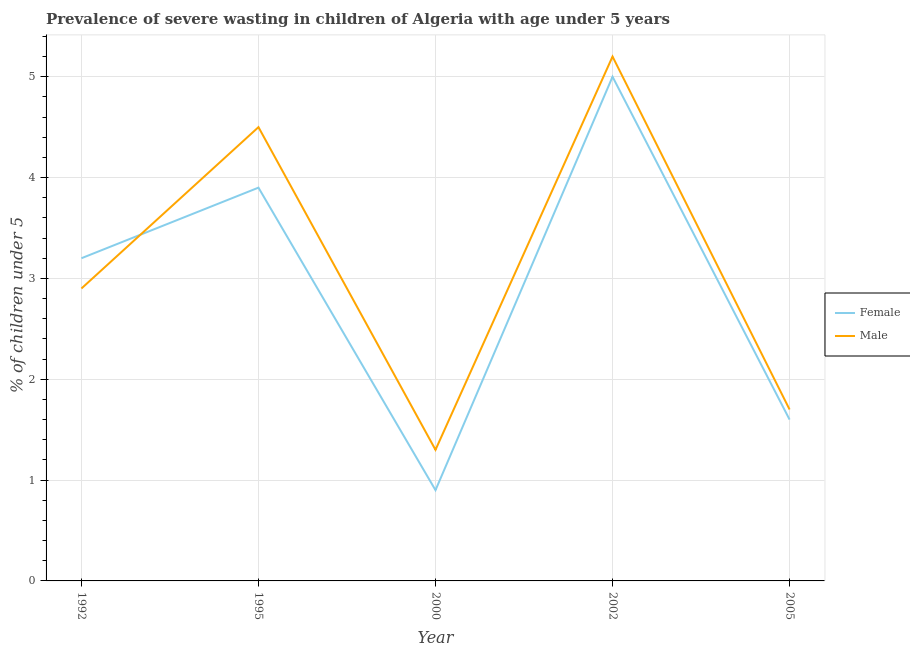Is the number of lines equal to the number of legend labels?
Offer a very short reply. Yes. What is the percentage of undernourished female children in 2000?
Provide a short and direct response. 0.9. Across all years, what is the maximum percentage of undernourished male children?
Keep it short and to the point. 5.2. Across all years, what is the minimum percentage of undernourished female children?
Your answer should be compact. 0.9. In which year was the percentage of undernourished male children minimum?
Your response must be concise. 2000. What is the total percentage of undernourished female children in the graph?
Provide a succinct answer. 14.6. What is the difference between the percentage of undernourished male children in 1992 and that in 2002?
Provide a short and direct response. -2.3. What is the difference between the percentage of undernourished male children in 2005 and the percentage of undernourished female children in 2000?
Make the answer very short. 0.8. What is the average percentage of undernourished female children per year?
Your answer should be very brief. 2.92. In the year 1992, what is the difference between the percentage of undernourished male children and percentage of undernourished female children?
Give a very brief answer. -0.3. What is the ratio of the percentage of undernourished female children in 1995 to that in 2005?
Give a very brief answer. 2.44. Is the difference between the percentage of undernourished male children in 2002 and 2005 greater than the difference between the percentage of undernourished female children in 2002 and 2005?
Offer a terse response. Yes. What is the difference between the highest and the second highest percentage of undernourished male children?
Offer a terse response. 0.7. What is the difference between the highest and the lowest percentage of undernourished female children?
Give a very brief answer. 4.1. In how many years, is the percentage of undernourished male children greater than the average percentage of undernourished male children taken over all years?
Your response must be concise. 2. Is the sum of the percentage of undernourished female children in 1992 and 1995 greater than the maximum percentage of undernourished male children across all years?
Give a very brief answer. Yes. Are the values on the major ticks of Y-axis written in scientific E-notation?
Offer a terse response. No. Does the graph contain any zero values?
Give a very brief answer. No. Does the graph contain grids?
Provide a short and direct response. Yes. Where does the legend appear in the graph?
Offer a terse response. Center right. How many legend labels are there?
Offer a very short reply. 2. What is the title of the graph?
Your answer should be very brief. Prevalence of severe wasting in children of Algeria with age under 5 years. What is the label or title of the Y-axis?
Offer a very short reply.  % of children under 5. What is the  % of children under 5 of Female in 1992?
Provide a short and direct response. 3.2. What is the  % of children under 5 in Male in 1992?
Provide a succinct answer. 2.9. What is the  % of children under 5 in Female in 1995?
Ensure brevity in your answer.  3.9. What is the  % of children under 5 in Male in 1995?
Ensure brevity in your answer.  4.5. What is the  % of children under 5 of Female in 2000?
Offer a very short reply. 0.9. What is the  % of children under 5 in Male in 2000?
Give a very brief answer. 1.3. What is the  % of children under 5 of Female in 2002?
Keep it short and to the point. 5. What is the  % of children under 5 of Male in 2002?
Your response must be concise. 5.2. What is the  % of children under 5 of Female in 2005?
Your answer should be compact. 1.6. What is the  % of children under 5 in Male in 2005?
Provide a short and direct response. 1.7. Across all years, what is the maximum  % of children under 5 of Female?
Ensure brevity in your answer.  5. Across all years, what is the maximum  % of children under 5 of Male?
Offer a very short reply. 5.2. Across all years, what is the minimum  % of children under 5 of Female?
Ensure brevity in your answer.  0.9. Across all years, what is the minimum  % of children under 5 of Male?
Make the answer very short. 1.3. What is the total  % of children under 5 in Female in the graph?
Offer a very short reply. 14.6. What is the difference between the  % of children under 5 in Female in 1992 and that in 2002?
Give a very brief answer. -1.8. What is the difference between the  % of children under 5 in Male in 1992 and that in 2002?
Provide a succinct answer. -2.3. What is the difference between the  % of children under 5 of Female in 1992 and that in 2005?
Ensure brevity in your answer.  1.6. What is the difference between the  % of children under 5 in Female in 1995 and that in 2000?
Keep it short and to the point. 3. What is the difference between the  % of children under 5 of Female in 1995 and that in 2005?
Make the answer very short. 2.3. What is the difference between the  % of children under 5 of Female in 2000 and that in 2002?
Your answer should be very brief. -4.1. What is the difference between the  % of children under 5 of Female in 2002 and that in 2005?
Your answer should be very brief. 3.4. What is the difference between the  % of children under 5 of Female in 1992 and the  % of children under 5 of Male in 1995?
Give a very brief answer. -1.3. What is the difference between the  % of children under 5 of Female in 1992 and the  % of children under 5 of Male in 2005?
Keep it short and to the point. 1.5. What is the difference between the  % of children under 5 of Female in 1995 and the  % of children under 5 of Male in 2005?
Offer a terse response. 2.2. What is the difference between the  % of children under 5 of Female in 2002 and the  % of children under 5 of Male in 2005?
Provide a succinct answer. 3.3. What is the average  % of children under 5 of Female per year?
Your answer should be compact. 2.92. What is the average  % of children under 5 of Male per year?
Your answer should be very brief. 3.12. In the year 1995, what is the difference between the  % of children under 5 of Female and  % of children under 5 of Male?
Give a very brief answer. -0.6. What is the ratio of the  % of children under 5 of Female in 1992 to that in 1995?
Provide a short and direct response. 0.82. What is the ratio of the  % of children under 5 in Male in 1992 to that in 1995?
Provide a succinct answer. 0.64. What is the ratio of the  % of children under 5 of Female in 1992 to that in 2000?
Your answer should be compact. 3.56. What is the ratio of the  % of children under 5 of Male in 1992 to that in 2000?
Your response must be concise. 2.23. What is the ratio of the  % of children under 5 in Female in 1992 to that in 2002?
Keep it short and to the point. 0.64. What is the ratio of the  % of children under 5 in Male in 1992 to that in 2002?
Give a very brief answer. 0.56. What is the ratio of the  % of children under 5 of Female in 1992 to that in 2005?
Provide a succinct answer. 2. What is the ratio of the  % of children under 5 of Male in 1992 to that in 2005?
Offer a very short reply. 1.71. What is the ratio of the  % of children under 5 of Female in 1995 to that in 2000?
Make the answer very short. 4.33. What is the ratio of the  % of children under 5 of Male in 1995 to that in 2000?
Your answer should be compact. 3.46. What is the ratio of the  % of children under 5 of Female in 1995 to that in 2002?
Provide a short and direct response. 0.78. What is the ratio of the  % of children under 5 in Male in 1995 to that in 2002?
Your response must be concise. 0.87. What is the ratio of the  % of children under 5 in Female in 1995 to that in 2005?
Provide a succinct answer. 2.44. What is the ratio of the  % of children under 5 in Male in 1995 to that in 2005?
Your answer should be very brief. 2.65. What is the ratio of the  % of children under 5 of Female in 2000 to that in 2002?
Ensure brevity in your answer.  0.18. What is the ratio of the  % of children under 5 of Male in 2000 to that in 2002?
Keep it short and to the point. 0.25. What is the ratio of the  % of children under 5 in Female in 2000 to that in 2005?
Provide a succinct answer. 0.56. What is the ratio of the  % of children under 5 of Male in 2000 to that in 2005?
Provide a short and direct response. 0.76. What is the ratio of the  % of children under 5 in Female in 2002 to that in 2005?
Make the answer very short. 3.12. What is the ratio of the  % of children under 5 of Male in 2002 to that in 2005?
Your answer should be very brief. 3.06. What is the difference between the highest and the second highest  % of children under 5 of Female?
Make the answer very short. 1.1. What is the difference between the highest and the second highest  % of children under 5 of Male?
Your answer should be compact. 0.7. What is the difference between the highest and the lowest  % of children under 5 of Male?
Offer a terse response. 3.9. 